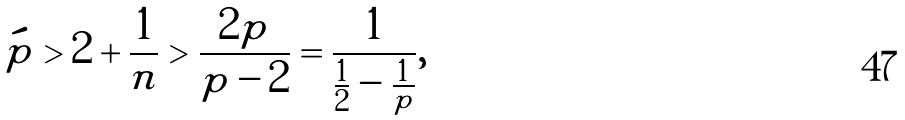Convert formula to latex. <formula><loc_0><loc_0><loc_500><loc_500>\acute { p } > 2 + \frac { 1 } { n } > \frac { 2 p } { p - 2 } = \frac { 1 } { \frac { 1 } { 2 } - \frac { 1 } { p } } ,</formula> 